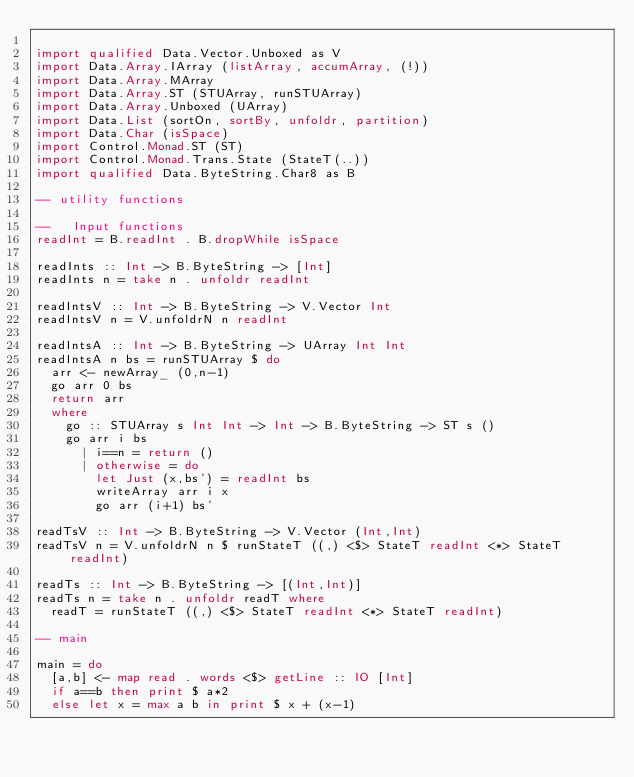Convert code to text. <code><loc_0><loc_0><loc_500><loc_500><_Haskell_>
import qualified Data.Vector.Unboxed as V
import Data.Array.IArray (listArray, accumArray, (!))
import Data.Array.MArray
import Data.Array.ST (STUArray, runSTUArray)
import Data.Array.Unboxed (UArray)
import Data.List (sortOn, sortBy, unfoldr, partition)
import Data.Char (isSpace)
import Control.Monad.ST (ST)
import Control.Monad.Trans.State (StateT(..))
import qualified Data.ByteString.Char8 as B

-- utility functions

--   Input functions
readInt = B.readInt . B.dropWhile isSpace

readInts :: Int -> B.ByteString -> [Int]
readInts n = take n . unfoldr readInt

readIntsV :: Int -> B.ByteString -> V.Vector Int
readIntsV n = V.unfoldrN n readInt

readIntsA :: Int -> B.ByteString -> UArray Int Int
readIntsA n bs = runSTUArray $ do
  arr <- newArray_ (0,n-1)
  go arr 0 bs
  return arr
  where
    go :: STUArray s Int Int -> Int -> B.ByteString -> ST s ()
    go arr i bs
      | i==n = return ()
      | otherwise = do
        let Just (x,bs') = readInt bs
        writeArray arr i x
        go arr (i+1) bs'

readTsV :: Int -> B.ByteString -> V.Vector (Int,Int)
readTsV n = V.unfoldrN n $ runStateT ((,) <$> StateT readInt <*> StateT readInt)

readTs :: Int -> B.ByteString -> [(Int,Int)]
readTs n = take n . unfoldr readT where
  readT = runStateT ((,) <$> StateT readInt <*> StateT readInt)

-- main

main = do
  [a,b] <- map read . words <$> getLine :: IO [Int]
  if a==b then print $ a*2
  else let x = max a b in print $ x + (x-1)
</code> 